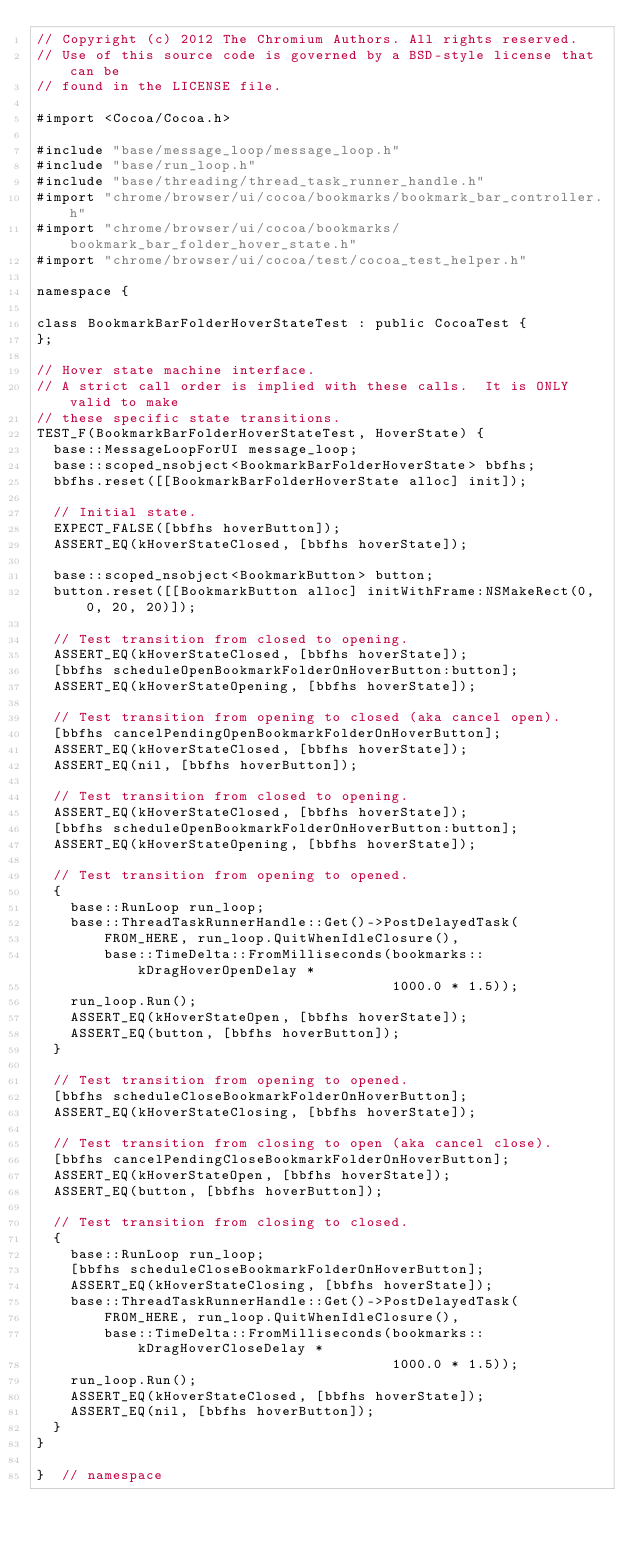<code> <loc_0><loc_0><loc_500><loc_500><_ObjectiveC_>// Copyright (c) 2012 The Chromium Authors. All rights reserved.
// Use of this source code is governed by a BSD-style license that can be
// found in the LICENSE file.

#import <Cocoa/Cocoa.h>

#include "base/message_loop/message_loop.h"
#include "base/run_loop.h"
#include "base/threading/thread_task_runner_handle.h"
#import "chrome/browser/ui/cocoa/bookmarks/bookmark_bar_controller.h"
#import "chrome/browser/ui/cocoa/bookmarks/bookmark_bar_folder_hover_state.h"
#import "chrome/browser/ui/cocoa/test/cocoa_test_helper.h"

namespace {

class BookmarkBarFolderHoverStateTest : public CocoaTest {
};

// Hover state machine interface.
// A strict call order is implied with these calls.  It is ONLY valid to make
// these specific state transitions.
TEST_F(BookmarkBarFolderHoverStateTest, HoverState) {
  base::MessageLoopForUI message_loop;
  base::scoped_nsobject<BookmarkBarFolderHoverState> bbfhs;
  bbfhs.reset([[BookmarkBarFolderHoverState alloc] init]);

  // Initial state.
  EXPECT_FALSE([bbfhs hoverButton]);
  ASSERT_EQ(kHoverStateClosed, [bbfhs hoverState]);

  base::scoped_nsobject<BookmarkButton> button;
  button.reset([[BookmarkButton alloc] initWithFrame:NSMakeRect(0, 0, 20, 20)]);

  // Test transition from closed to opening.
  ASSERT_EQ(kHoverStateClosed, [bbfhs hoverState]);
  [bbfhs scheduleOpenBookmarkFolderOnHoverButton:button];
  ASSERT_EQ(kHoverStateOpening, [bbfhs hoverState]);

  // Test transition from opening to closed (aka cancel open).
  [bbfhs cancelPendingOpenBookmarkFolderOnHoverButton];
  ASSERT_EQ(kHoverStateClosed, [bbfhs hoverState]);
  ASSERT_EQ(nil, [bbfhs hoverButton]);

  // Test transition from closed to opening.
  ASSERT_EQ(kHoverStateClosed, [bbfhs hoverState]);
  [bbfhs scheduleOpenBookmarkFolderOnHoverButton:button];
  ASSERT_EQ(kHoverStateOpening, [bbfhs hoverState]);

  // Test transition from opening to opened.
  {
    base::RunLoop run_loop;
    base::ThreadTaskRunnerHandle::Get()->PostDelayedTask(
        FROM_HERE, run_loop.QuitWhenIdleClosure(),
        base::TimeDelta::FromMilliseconds(bookmarks::kDragHoverOpenDelay *
                                          1000.0 * 1.5));
    run_loop.Run();
    ASSERT_EQ(kHoverStateOpen, [bbfhs hoverState]);
    ASSERT_EQ(button, [bbfhs hoverButton]);
  }

  // Test transition from opening to opened.
  [bbfhs scheduleCloseBookmarkFolderOnHoverButton];
  ASSERT_EQ(kHoverStateClosing, [bbfhs hoverState]);

  // Test transition from closing to open (aka cancel close).
  [bbfhs cancelPendingCloseBookmarkFolderOnHoverButton];
  ASSERT_EQ(kHoverStateOpen, [bbfhs hoverState]);
  ASSERT_EQ(button, [bbfhs hoverButton]);

  // Test transition from closing to closed.
  {
    base::RunLoop run_loop;
    [bbfhs scheduleCloseBookmarkFolderOnHoverButton];
    ASSERT_EQ(kHoverStateClosing, [bbfhs hoverState]);
    base::ThreadTaskRunnerHandle::Get()->PostDelayedTask(
        FROM_HERE, run_loop.QuitWhenIdleClosure(),
        base::TimeDelta::FromMilliseconds(bookmarks::kDragHoverCloseDelay *
                                          1000.0 * 1.5));
    run_loop.Run();
    ASSERT_EQ(kHoverStateClosed, [bbfhs hoverState]);
    ASSERT_EQ(nil, [bbfhs hoverButton]);
  }
}

}  // namespace
</code> 